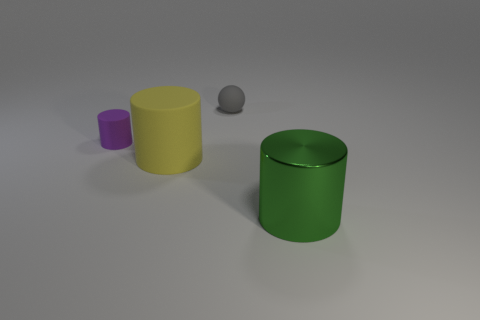Subtract all big cylinders. How many cylinders are left? 1 Add 2 big things. How many objects exist? 6 Subtract all green cylinders. How many cylinders are left? 2 Subtract all spheres. How many objects are left? 3 Add 2 big cylinders. How many big cylinders are left? 4 Add 4 big blocks. How many big blocks exist? 4 Subtract 1 green cylinders. How many objects are left? 3 Subtract 2 cylinders. How many cylinders are left? 1 Subtract all cyan balls. Subtract all blue cubes. How many balls are left? 1 Subtract all green spheres. How many green cylinders are left? 1 